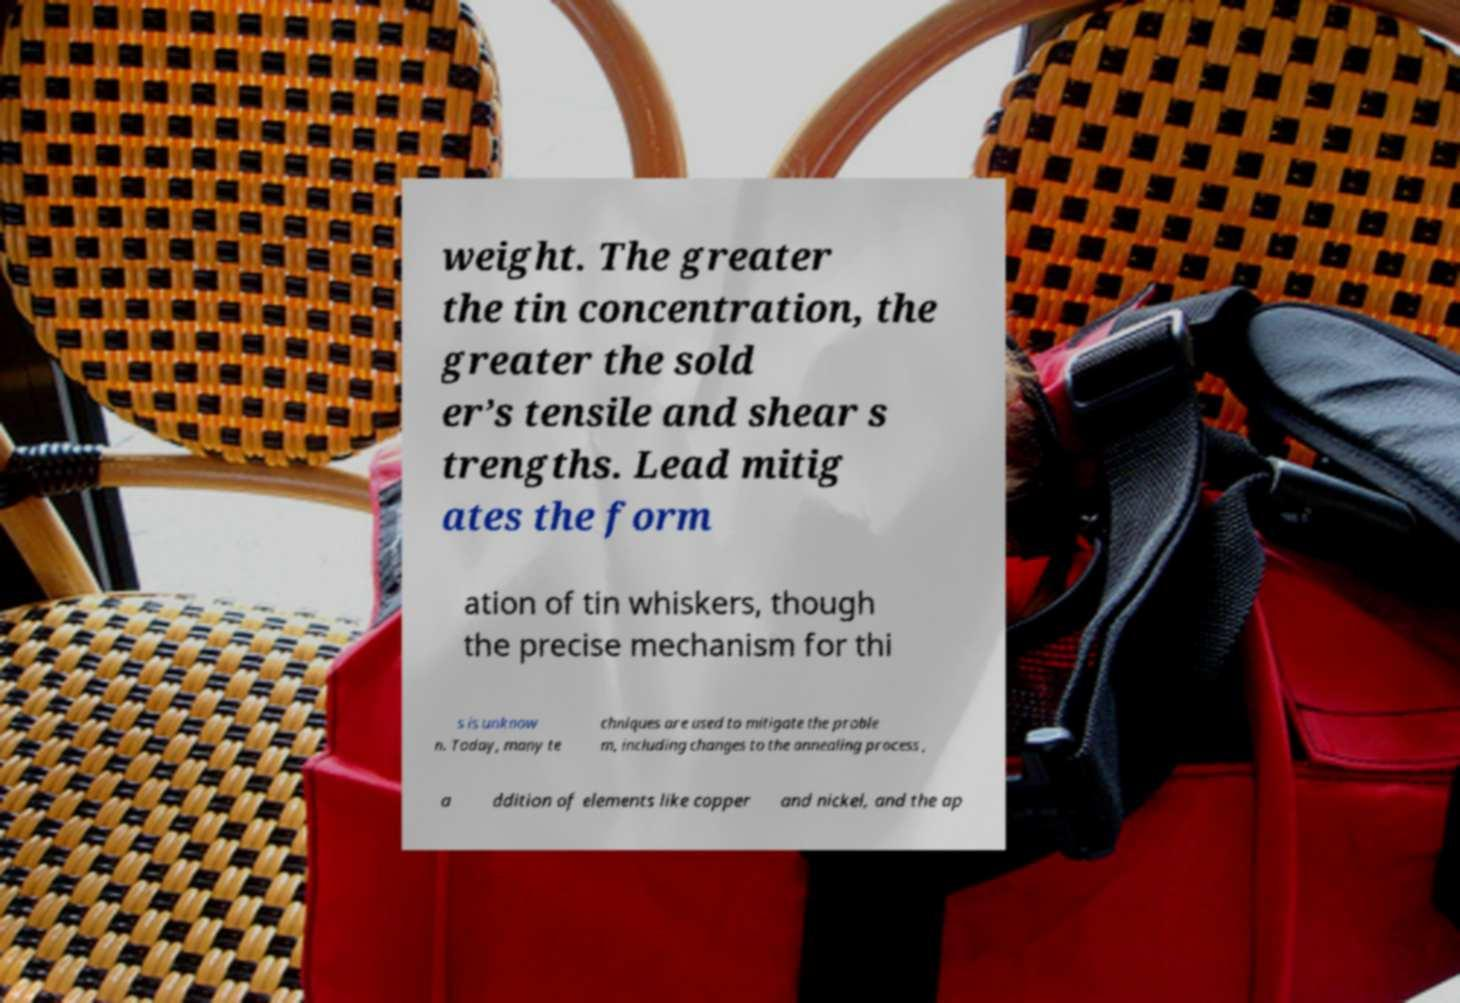What messages or text are displayed in this image? I need them in a readable, typed format. weight. The greater the tin concentration, the greater the sold er’s tensile and shear s trengths. Lead mitig ates the form ation of tin whiskers, though the precise mechanism for thi s is unknow n. Today, many te chniques are used to mitigate the proble m, including changes to the annealing process , a ddition of elements like copper and nickel, and the ap 